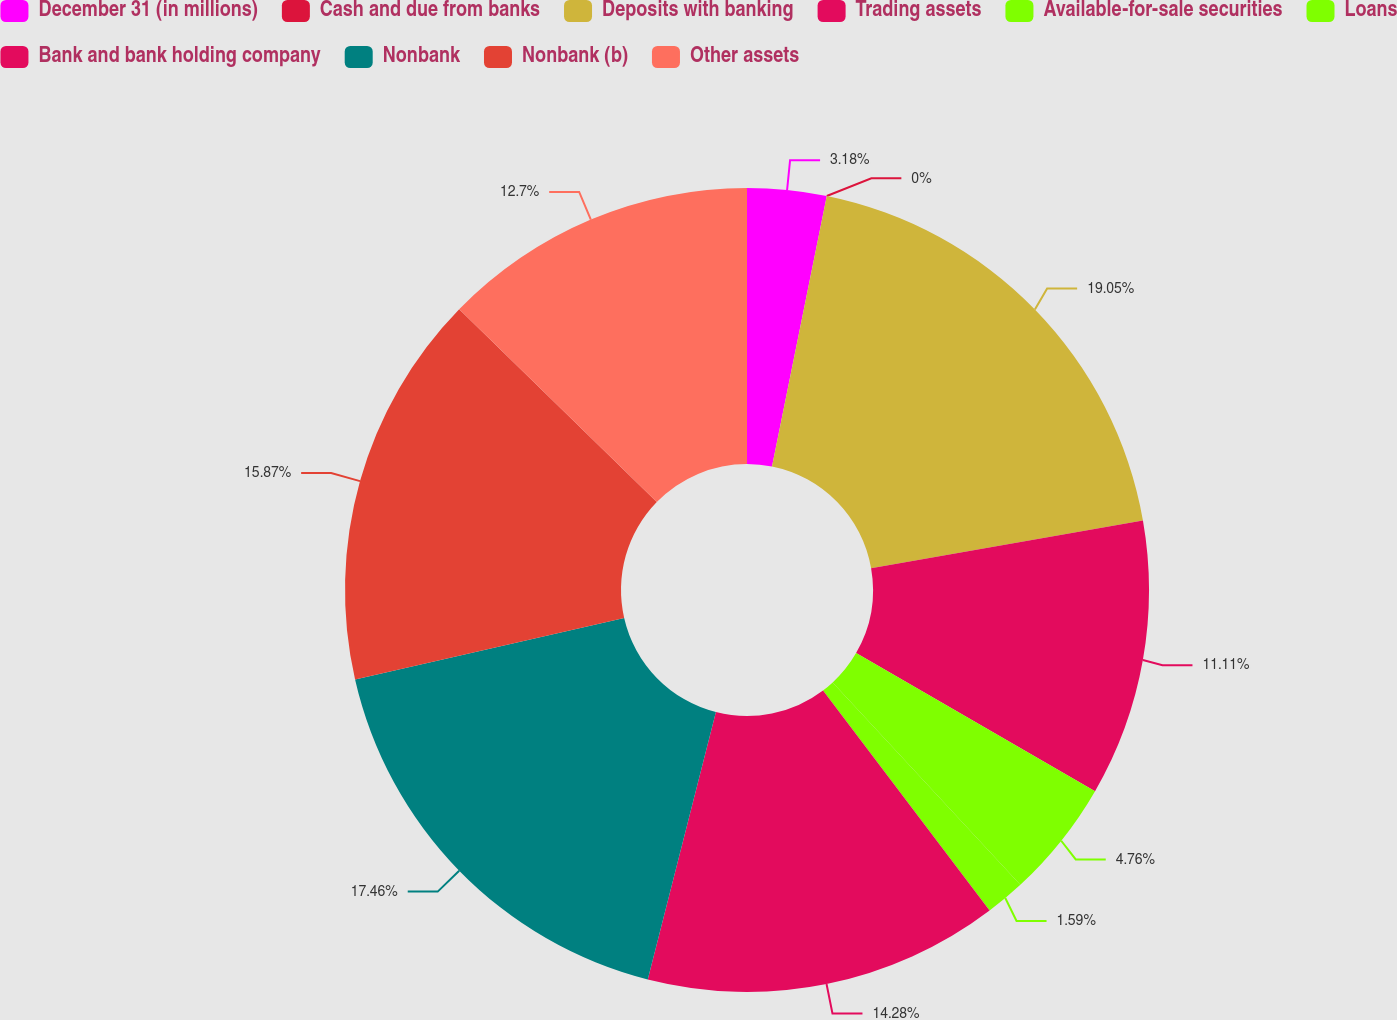Convert chart to OTSL. <chart><loc_0><loc_0><loc_500><loc_500><pie_chart><fcel>December 31 (in millions)<fcel>Cash and due from banks<fcel>Deposits with banking<fcel>Trading assets<fcel>Available-for-sale securities<fcel>Loans<fcel>Bank and bank holding company<fcel>Nonbank<fcel>Nonbank (b)<fcel>Other assets<nl><fcel>3.18%<fcel>0.0%<fcel>19.05%<fcel>11.11%<fcel>4.76%<fcel>1.59%<fcel>14.28%<fcel>17.46%<fcel>15.87%<fcel>12.7%<nl></chart> 